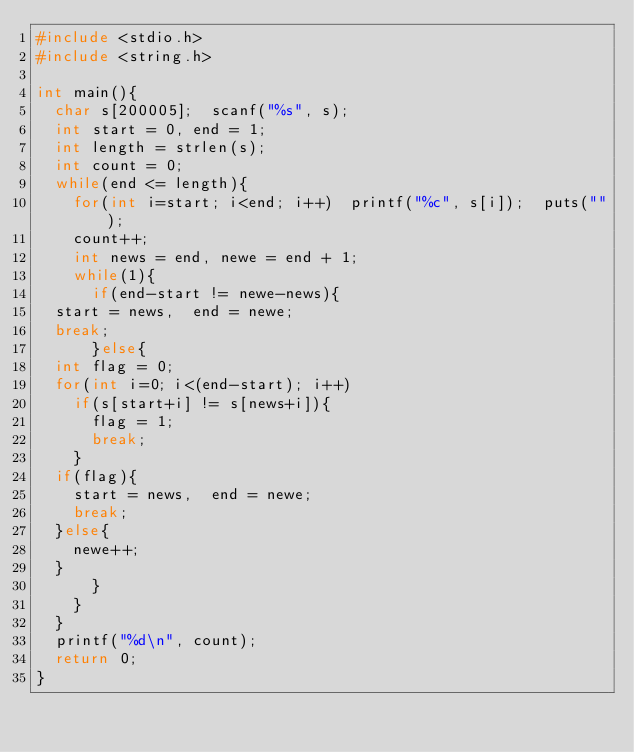<code> <loc_0><loc_0><loc_500><loc_500><_C_>#include <stdio.h>
#include <string.h>

int main(){
  char s[200005];  scanf("%s", s);
  int start = 0, end = 1;
  int length = strlen(s);
  int count = 0;
  while(end <= length){
    for(int i=start; i<end; i++)  printf("%c", s[i]);  puts("");
    count++;
    int news = end, newe = end + 1;
    while(1){
      if(end-start != newe-news){
	start = news,  end = newe;
	break;
      }else{
	int flag = 0;
	for(int i=0; i<(end-start); i++)
	  if(s[start+i] != s[news+i]){
	    flag = 1;
	    break;
	  }
	if(flag){
	  start = news,  end = newe;
	  break;
	}else{
	  newe++;
	}
      }
    }
  }
  printf("%d\n", count);
  return 0;
}
</code> 